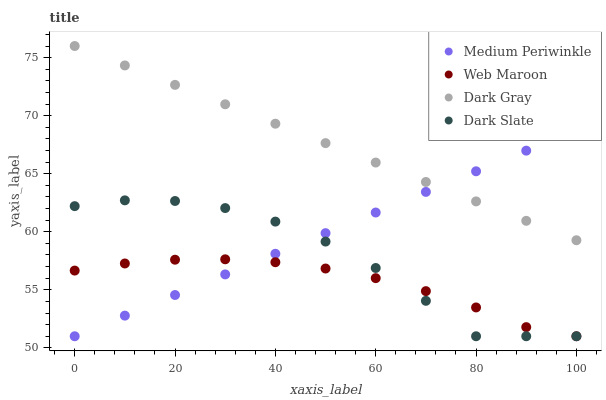Does Web Maroon have the minimum area under the curve?
Answer yes or no. Yes. Does Dark Gray have the maximum area under the curve?
Answer yes or no. Yes. Does Medium Periwinkle have the minimum area under the curve?
Answer yes or no. No. Does Medium Periwinkle have the maximum area under the curve?
Answer yes or no. No. Is Dark Gray the smoothest?
Answer yes or no. Yes. Is Dark Slate the roughest?
Answer yes or no. Yes. Is Web Maroon the smoothest?
Answer yes or no. No. Is Web Maroon the roughest?
Answer yes or no. No. Does Web Maroon have the lowest value?
Answer yes or no. Yes. Does Dark Gray have the highest value?
Answer yes or no. Yes. Does Medium Periwinkle have the highest value?
Answer yes or no. No. Is Dark Slate less than Dark Gray?
Answer yes or no. Yes. Is Dark Gray greater than Dark Slate?
Answer yes or no. Yes. Does Dark Slate intersect Medium Periwinkle?
Answer yes or no. Yes. Is Dark Slate less than Medium Periwinkle?
Answer yes or no. No. Is Dark Slate greater than Medium Periwinkle?
Answer yes or no. No. Does Dark Slate intersect Dark Gray?
Answer yes or no. No. 